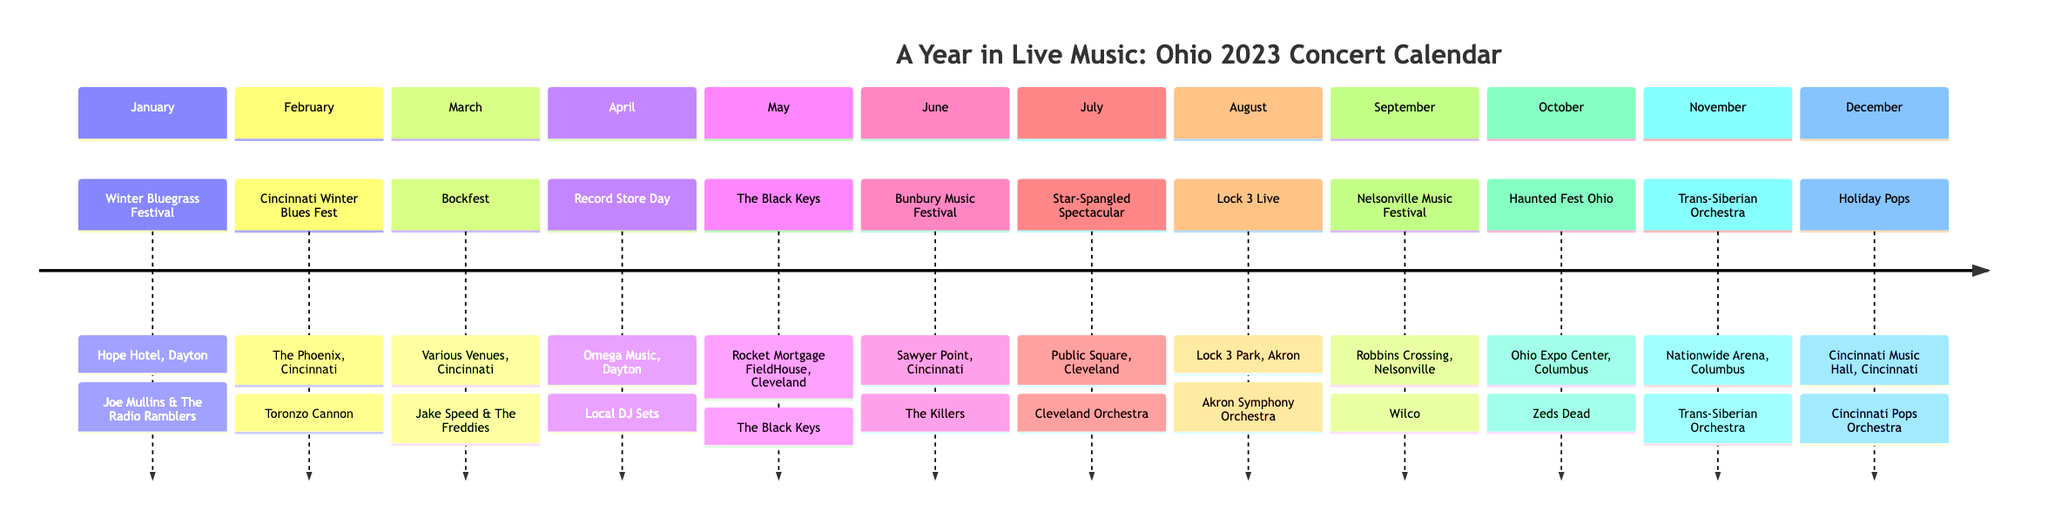What event is scheduled in June? The diagram indicates that in June, the event is the Bunbury Music Festival at Sawyer Point in Cincinnati. The specific highlight artist for this event is The Killers.
Answer: Bunbury Music Festival How many events are listed for the month of November? In the diagram, November has one event listed, which is the Trans-Siberian Orchestra concert at Nationwide Arena in Columbus.
Answer: 1 Which venue hosts the Holiday Pops? The diagram shows that the Holiday Pops is hosted at the Cincinnati Music Hall in Cincinnati during December.
Answer: Cincinnati Music Hall Name the artist performing at the Star-Spangled Spectacular. The artist performing at the Star-Spangled Spectacular, according to the diagram, is the Cleveland Orchestra at Public Square in Cleveland.
Answer: Cleveland Orchestra In which month does the record store day event occur? The diagram indicates that the Record Store Day event takes place in April at Omega Music in Dayton.
Answer: April Which festival takes place in September? The diagram outlines that the event in September is the Nelsonville Music Festival, featuring Wilco at Robbins Crossing in Nelsonville.
Answer: Nelsonville Music Festival What is the highlight artist for February's concert? According to the diagram, the highlight artist for the Cincinnati Winter Blues Fest in February is Toronzo Cannon, performed at The Phoenix in Cincinnati.
Answer: Toronzo Cannon Which concert is scheduled for October? The diagram displays that the concert in October is the Haunted Fest Ohio at the Ohio Expo Center in Columbus, featuring Zeds Dead.
Answer: Haunted Fest Ohio How many concerts take place in the summer months (June, July, August)? The diagram specifies three events taking place in the summer: June (Bunbury Music Festival), July (Star-Spangled Spectacular), and August (Lock 3 Live). Therefore, the total is three.
Answer: 3 